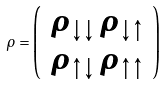Convert formula to latex. <formula><loc_0><loc_0><loc_500><loc_500>\rho = \left ( \begin{array} { c c } \rho _ { \downarrow \downarrow } \, \rho _ { \downarrow \uparrow } \\ \rho _ { \uparrow \downarrow } \, \rho _ { \uparrow \uparrow } \end{array} \right )</formula> 